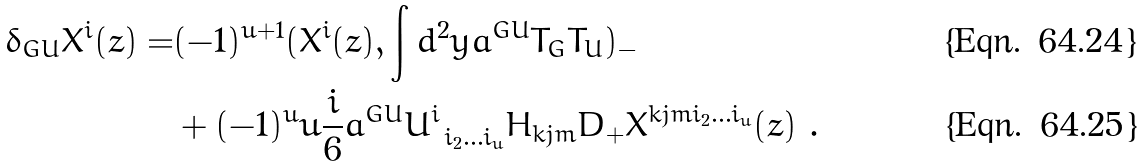Convert formula to latex. <formula><loc_0><loc_0><loc_500><loc_500>\delta _ { G U } X ^ { i } ( z ) = & ( - 1 ) ^ { u + 1 } ( X ^ { i } ( z ) , \int d ^ { 2 } y a ^ { G U } T _ { G } T _ { U } ) _ { - } \\ & + ( - 1 ) ^ { u } u \frac { i } { 6 } a ^ { G U } U ^ { i } _ { \ i _ { 2 } \dots i _ { u } } H _ { k j m } D _ { + } X ^ { k j m i _ { 2 } \dots i _ { u } } ( z ) \ .</formula> 